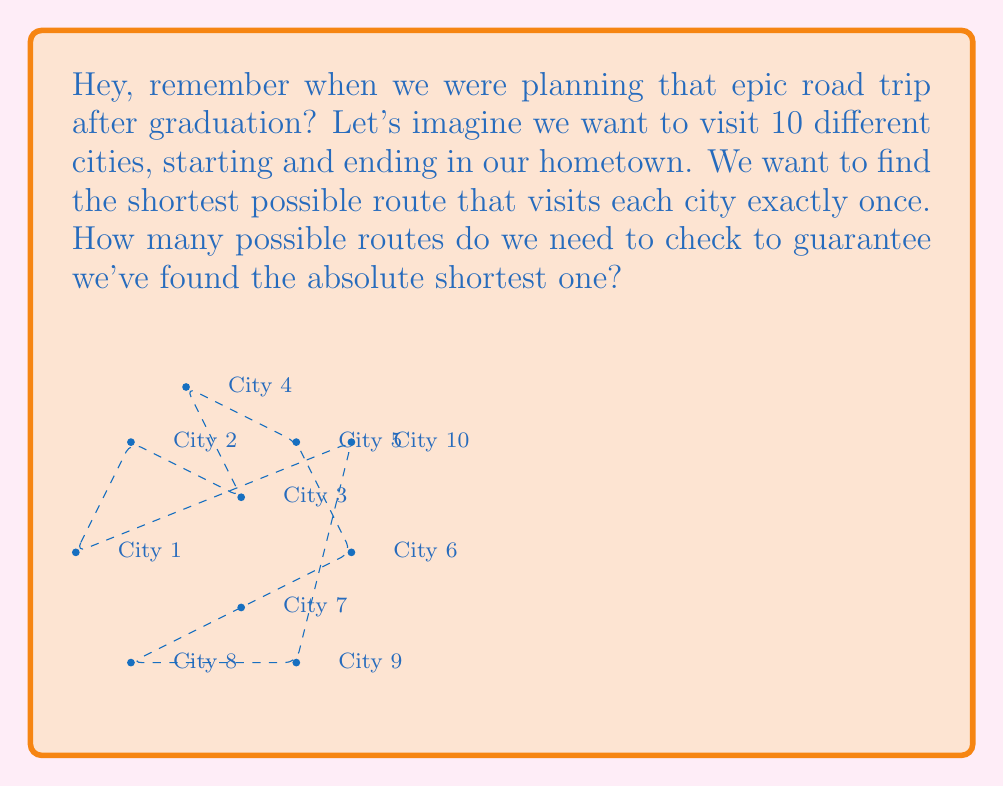Give your solution to this math problem. Let's break this down step-by-step:

1) This problem is known as the Traveling Salesman Problem (TSP), which is a classic example of an NP-complete problem.

2) NP-complete problems are characterized by:
   - Being in NP (solvable in polynomial time on a non-deterministic machine)
   - Being at least as hard as any other problem in NP

3) For our road trip with 10 cities:
   - We start in our hometown (1 choice)
   - For the next city, we have 9 choices
   - For the third city, 8 choices, and so on

4) This gives us a permutation of 9 cities (excluding our hometown):
   $$(9 \times 8 \times 7 \times 6 \times 5 \times 4 \times 3 \times 2 \times 1) = 9!$$

5) However, we can start our tour from any city and go in either direction, so we need to divide by 2:
   $$\frac{9!}{2} = 181,440$$

6) This number grows factorially with the number of cities. For n cities, it's $\frac{(n-1)!}{2}$.

7) The factorial growth means that as the number of cities increases, the number of possible routes grows extremely quickly, making it impractical to check all routes for even a modest number of cities.

8) This exponential growth in complexity is a key characteristic of NP-complete problems, making them intractable for large inputs using known algorithms.
Answer: 181,440 routes 